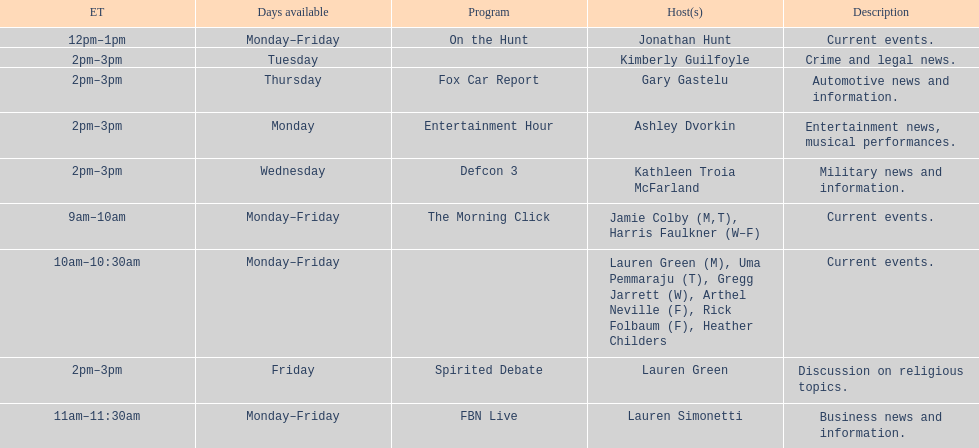How long does on the hunt run? 1 hour. 